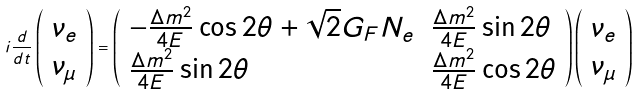<formula> <loc_0><loc_0><loc_500><loc_500>i \frac { d } { d t } \left ( \begin{array} { c } \nu _ { e } \\ \nu _ { \mu } \end{array} \right ) = \left ( \begin{array} { l l } - \frac { \Delta m ^ { 2 } } { 4 E } \cos 2 \theta + \sqrt { 2 } G _ { F } N _ { e } & \frac { \Delta m ^ { 2 } } { 4 E } \sin 2 \theta \\ \frac { \Delta m ^ { 2 } } { 4 E } \sin 2 \theta & \frac { \Delta m ^ { 2 } } { 4 E } \cos 2 \theta \\ \end{array} \right ) \left ( \begin{array} { c } \nu _ { e } \\ \nu _ { \mu } \end{array} \right )</formula> 